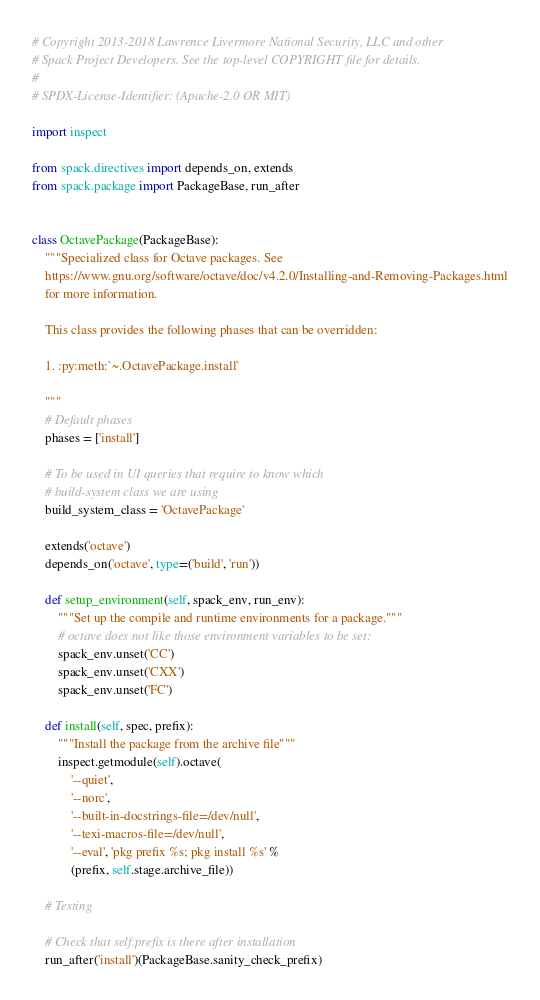<code> <loc_0><loc_0><loc_500><loc_500><_Python_># Copyright 2013-2018 Lawrence Livermore National Security, LLC and other
# Spack Project Developers. See the top-level COPYRIGHT file for details.
#
# SPDX-License-Identifier: (Apache-2.0 OR MIT)

import inspect

from spack.directives import depends_on, extends
from spack.package import PackageBase, run_after


class OctavePackage(PackageBase):
    """Specialized class for Octave packages. See
    https://www.gnu.org/software/octave/doc/v4.2.0/Installing-and-Removing-Packages.html
    for more information.

    This class provides the following phases that can be overridden:

    1. :py:meth:`~.OctavePackage.install`

    """
    # Default phases
    phases = ['install']

    # To be used in UI queries that require to know which
    # build-system class we are using
    build_system_class = 'OctavePackage'

    extends('octave')
    depends_on('octave', type=('build', 'run'))

    def setup_environment(self, spack_env, run_env):
        """Set up the compile and runtime environments for a package."""
        # octave does not like those environment variables to be set:
        spack_env.unset('CC')
        spack_env.unset('CXX')
        spack_env.unset('FC')

    def install(self, spec, prefix):
        """Install the package from the archive file"""
        inspect.getmodule(self).octave(
            '--quiet',
            '--norc',
            '--built-in-docstrings-file=/dev/null',
            '--texi-macros-file=/dev/null',
            '--eval', 'pkg prefix %s; pkg install %s' %
            (prefix, self.stage.archive_file))

    # Testing

    # Check that self.prefix is there after installation
    run_after('install')(PackageBase.sanity_check_prefix)
</code> 